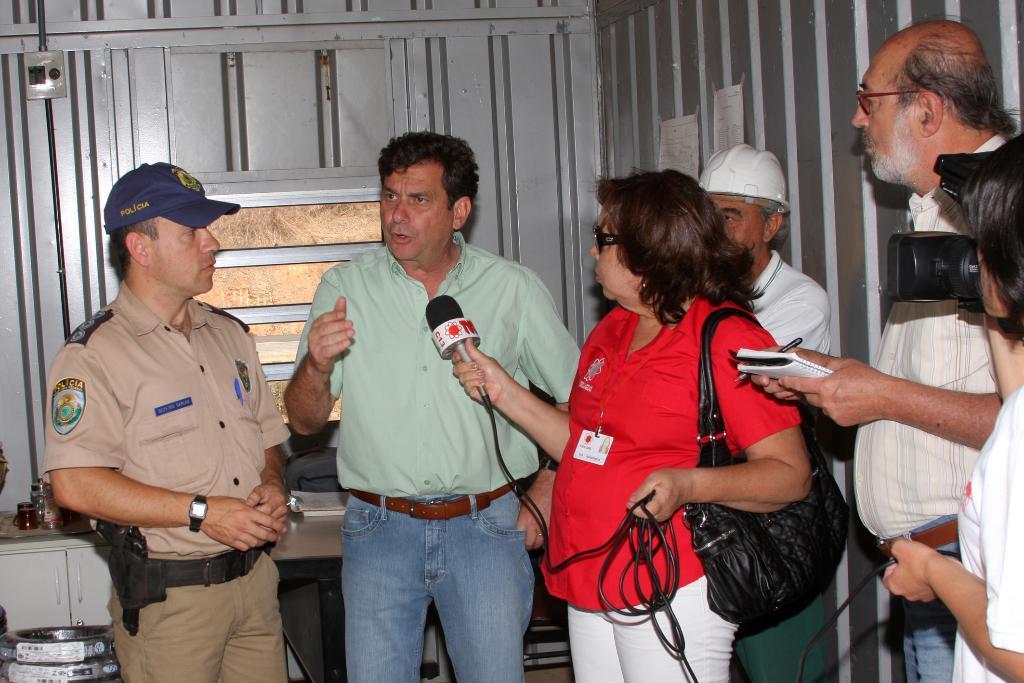How would you summarize this image in a sentence or two? In the center of the image we can see a few people are standing and few people are holding some objects. And on the right side of the image, we can see one person holding a camera. Among them, we can see one person is wearing a cap and one person is wearing a helmet. In the background we can see posters, one table, cupboards, one window, one dustbin and a few other objects. 